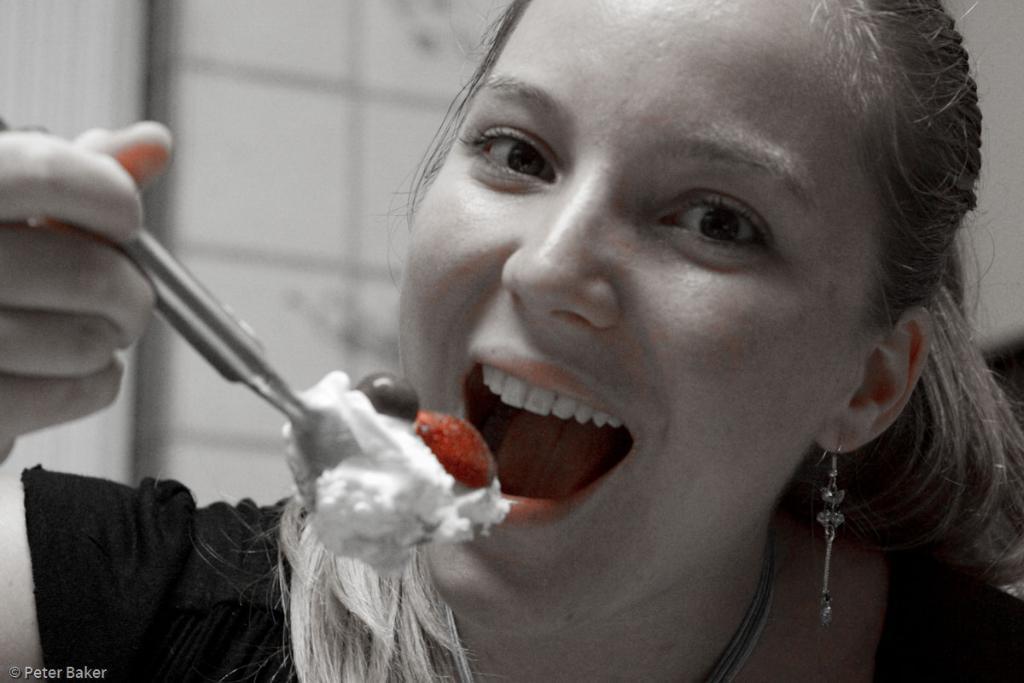Could you give a brief overview of what you see in this image? In this image there is a woman holding a spoon, on the spoon there is a food item, in the bottom left there is a text visible. 